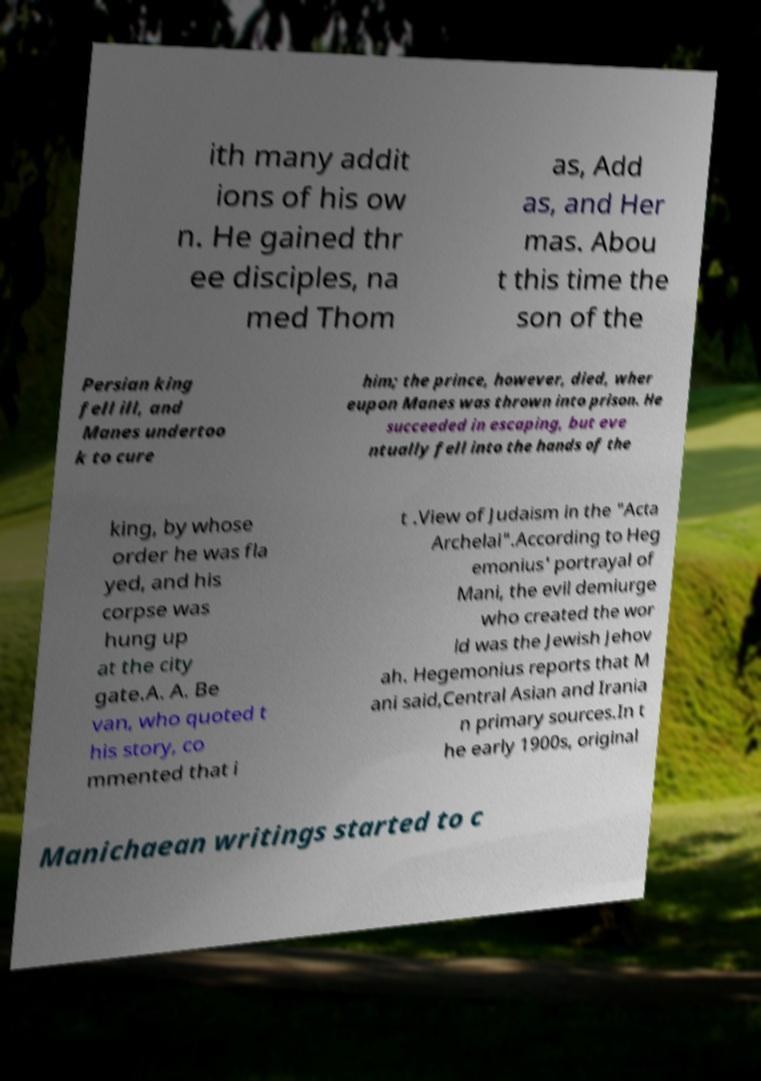I need the written content from this picture converted into text. Can you do that? ith many addit ions of his ow n. He gained thr ee disciples, na med Thom as, Add as, and Her mas. Abou t this time the son of the Persian king fell ill, and Manes undertoo k to cure him; the prince, however, died, wher eupon Manes was thrown into prison. He succeeded in escaping, but eve ntually fell into the hands of the king, by whose order he was fla yed, and his corpse was hung up at the city gate.A. A. Be van, who quoted t his story, co mmented that i t .View of Judaism in the "Acta Archelai".According to Heg emonius' portrayal of Mani, the evil demiurge who created the wor ld was the Jewish Jehov ah. Hegemonius reports that M ani said,Central Asian and Irania n primary sources.In t he early 1900s, original Manichaean writings started to c 